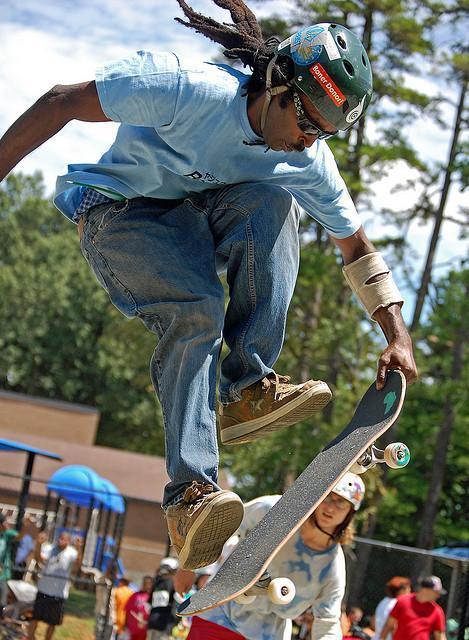How many people are there?
Give a very brief answer. 5. 